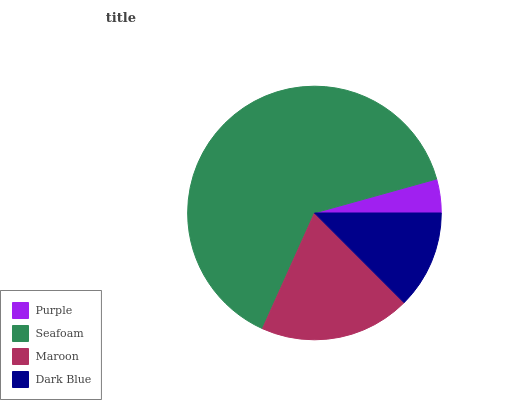Is Purple the minimum?
Answer yes or no. Yes. Is Seafoam the maximum?
Answer yes or no. Yes. Is Maroon the minimum?
Answer yes or no. No. Is Maroon the maximum?
Answer yes or no. No. Is Seafoam greater than Maroon?
Answer yes or no. Yes. Is Maroon less than Seafoam?
Answer yes or no. Yes. Is Maroon greater than Seafoam?
Answer yes or no. No. Is Seafoam less than Maroon?
Answer yes or no. No. Is Maroon the high median?
Answer yes or no. Yes. Is Dark Blue the low median?
Answer yes or no. Yes. Is Seafoam the high median?
Answer yes or no. No. Is Purple the low median?
Answer yes or no. No. 